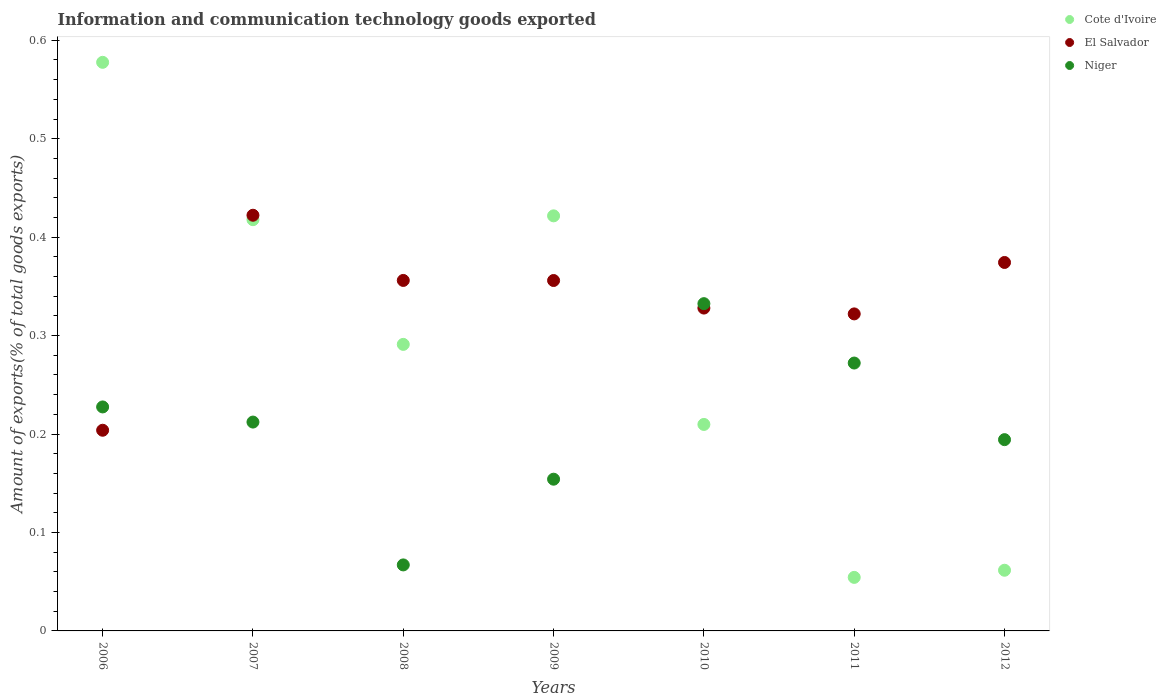Is the number of dotlines equal to the number of legend labels?
Provide a succinct answer. Yes. What is the amount of goods exported in Niger in 2007?
Provide a short and direct response. 0.21. Across all years, what is the maximum amount of goods exported in El Salvador?
Your response must be concise. 0.42. Across all years, what is the minimum amount of goods exported in Niger?
Offer a terse response. 0.07. In which year was the amount of goods exported in El Salvador minimum?
Provide a succinct answer. 2006. What is the total amount of goods exported in Cote d'Ivoire in the graph?
Keep it short and to the point. 2.03. What is the difference between the amount of goods exported in El Salvador in 2008 and that in 2011?
Provide a short and direct response. 0.03. What is the difference between the amount of goods exported in El Salvador in 2009 and the amount of goods exported in Niger in 2008?
Provide a short and direct response. 0.29. What is the average amount of goods exported in Cote d'Ivoire per year?
Your answer should be very brief. 0.29. In the year 2008, what is the difference between the amount of goods exported in Niger and amount of goods exported in Cote d'Ivoire?
Make the answer very short. -0.22. What is the ratio of the amount of goods exported in El Salvador in 2010 to that in 2011?
Your answer should be very brief. 1.02. What is the difference between the highest and the second highest amount of goods exported in Niger?
Provide a short and direct response. 0.06. What is the difference between the highest and the lowest amount of goods exported in Cote d'Ivoire?
Make the answer very short. 0.52. Is it the case that in every year, the sum of the amount of goods exported in Niger and amount of goods exported in Cote d'Ivoire  is greater than the amount of goods exported in El Salvador?
Provide a succinct answer. No. Does the amount of goods exported in Cote d'Ivoire monotonically increase over the years?
Offer a terse response. No. How many years are there in the graph?
Offer a terse response. 7. What is the difference between two consecutive major ticks on the Y-axis?
Keep it short and to the point. 0.1. Are the values on the major ticks of Y-axis written in scientific E-notation?
Offer a very short reply. No. Does the graph contain any zero values?
Provide a succinct answer. No. Where does the legend appear in the graph?
Ensure brevity in your answer.  Top right. How many legend labels are there?
Offer a terse response. 3. How are the legend labels stacked?
Your answer should be compact. Vertical. What is the title of the graph?
Your response must be concise. Information and communication technology goods exported. What is the label or title of the Y-axis?
Keep it short and to the point. Amount of exports(% of total goods exports). What is the Amount of exports(% of total goods exports) in Cote d'Ivoire in 2006?
Ensure brevity in your answer.  0.58. What is the Amount of exports(% of total goods exports) of El Salvador in 2006?
Make the answer very short. 0.2. What is the Amount of exports(% of total goods exports) of Niger in 2006?
Keep it short and to the point. 0.23. What is the Amount of exports(% of total goods exports) in Cote d'Ivoire in 2007?
Your answer should be compact. 0.42. What is the Amount of exports(% of total goods exports) in El Salvador in 2007?
Give a very brief answer. 0.42. What is the Amount of exports(% of total goods exports) in Niger in 2007?
Keep it short and to the point. 0.21. What is the Amount of exports(% of total goods exports) in Cote d'Ivoire in 2008?
Provide a short and direct response. 0.29. What is the Amount of exports(% of total goods exports) of El Salvador in 2008?
Give a very brief answer. 0.36. What is the Amount of exports(% of total goods exports) in Niger in 2008?
Your answer should be very brief. 0.07. What is the Amount of exports(% of total goods exports) of Cote d'Ivoire in 2009?
Your answer should be very brief. 0.42. What is the Amount of exports(% of total goods exports) of El Salvador in 2009?
Offer a very short reply. 0.36. What is the Amount of exports(% of total goods exports) in Niger in 2009?
Offer a terse response. 0.15. What is the Amount of exports(% of total goods exports) in Cote d'Ivoire in 2010?
Provide a short and direct response. 0.21. What is the Amount of exports(% of total goods exports) in El Salvador in 2010?
Give a very brief answer. 0.33. What is the Amount of exports(% of total goods exports) of Niger in 2010?
Offer a very short reply. 0.33. What is the Amount of exports(% of total goods exports) of Cote d'Ivoire in 2011?
Offer a very short reply. 0.05. What is the Amount of exports(% of total goods exports) in El Salvador in 2011?
Your response must be concise. 0.32. What is the Amount of exports(% of total goods exports) in Niger in 2011?
Offer a terse response. 0.27. What is the Amount of exports(% of total goods exports) in Cote d'Ivoire in 2012?
Your answer should be compact. 0.06. What is the Amount of exports(% of total goods exports) of El Salvador in 2012?
Provide a succinct answer. 0.37. What is the Amount of exports(% of total goods exports) in Niger in 2012?
Provide a succinct answer. 0.19. Across all years, what is the maximum Amount of exports(% of total goods exports) in Cote d'Ivoire?
Offer a very short reply. 0.58. Across all years, what is the maximum Amount of exports(% of total goods exports) of El Salvador?
Give a very brief answer. 0.42. Across all years, what is the maximum Amount of exports(% of total goods exports) in Niger?
Ensure brevity in your answer.  0.33. Across all years, what is the minimum Amount of exports(% of total goods exports) of Cote d'Ivoire?
Your answer should be very brief. 0.05. Across all years, what is the minimum Amount of exports(% of total goods exports) of El Salvador?
Your answer should be very brief. 0.2. Across all years, what is the minimum Amount of exports(% of total goods exports) in Niger?
Your answer should be compact. 0.07. What is the total Amount of exports(% of total goods exports) in Cote d'Ivoire in the graph?
Offer a terse response. 2.03. What is the total Amount of exports(% of total goods exports) of El Salvador in the graph?
Your answer should be very brief. 2.36. What is the total Amount of exports(% of total goods exports) in Niger in the graph?
Provide a short and direct response. 1.46. What is the difference between the Amount of exports(% of total goods exports) in Cote d'Ivoire in 2006 and that in 2007?
Keep it short and to the point. 0.16. What is the difference between the Amount of exports(% of total goods exports) in El Salvador in 2006 and that in 2007?
Provide a succinct answer. -0.22. What is the difference between the Amount of exports(% of total goods exports) of Niger in 2006 and that in 2007?
Provide a short and direct response. 0.02. What is the difference between the Amount of exports(% of total goods exports) in Cote d'Ivoire in 2006 and that in 2008?
Provide a succinct answer. 0.29. What is the difference between the Amount of exports(% of total goods exports) in El Salvador in 2006 and that in 2008?
Provide a short and direct response. -0.15. What is the difference between the Amount of exports(% of total goods exports) in Niger in 2006 and that in 2008?
Ensure brevity in your answer.  0.16. What is the difference between the Amount of exports(% of total goods exports) of Cote d'Ivoire in 2006 and that in 2009?
Provide a succinct answer. 0.16. What is the difference between the Amount of exports(% of total goods exports) of El Salvador in 2006 and that in 2009?
Your answer should be compact. -0.15. What is the difference between the Amount of exports(% of total goods exports) in Niger in 2006 and that in 2009?
Your response must be concise. 0.07. What is the difference between the Amount of exports(% of total goods exports) in Cote d'Ivoire in 2006 and that in 2010?
Make the answer very short. 0.37. What is the difference between the Amount of exports(% of total goods exports) in El Salvador in 2006 and that in 2010?
Your answer should be compact. -0.12. What is the difference between the Amount of exports(% of total goods exports) of Niger in 2006 and that in 2010?
Keep it short and to the point. -0.1. What is the difference between the Amount of exports(% of total goods exports) of Cote d'Ivoire in 2006 and that in 2011?
Provide a short and direct response. 0.52. What is the difference between the Amount of exports(% of total goods exports) in El Salvador in 2006 and that in 2011?
Your answer should be very brief. -0.12. What is the difference between the Amount of exports(% of total goods exports) in Niger in 2006 and that in 2011?
Provide a short and direct response. -0.04. What is the difference between the Amount of exports(% of total goods exports) in Cote d'Ivoire in 2006 and that in 2012?
Ensure brevity in your answer.  0.52. What is the difference between the Amount of exports(% of total goods exports) in El Salvador in 2006 and that in 2012?
Ensure brevity in your answer.  -0.17. What is the difference between the Amount of exports(% of total goods exports) in Niger in 2006 and that in 2012?
Provide a succinct answer. 0.03. What is the difference between the Amount of exports(% of total goods exports) in Cote d'Ivoire in 2007 and that in 2008?
Your response must be concise. 0.13. What is the difference between the Amount of exports(% of total goods exports) of El Salvador in 2007 and that in 2008?
Your answer should be very brief. 0.07. What is the difference between the Amount of exports(% of total goods exports) of Niger in 2007 and that in 2008?
Ensure brevity in your answer.  0.15. What is the difference between the Amount of exports(% of total goods exports) of Cote d'Ivoire in 2007 and that in 2009?
Offer a very short reply. -0. What is the difference between the Amount of exports(% of total goods exports) of El Salvador in 2007 and that in 2009?
Your answer should be very brief. 0.07. What is the difference between the Amount of exports(% of total goods exports) of Niger in 2007 and that in 2009?
Provide a succinct answer. 0.06. What is the difference between the Amount of exports(% of total goods exports) in Cote d'Ivoire in 2007 and that in 2010?
Provide a short and direct response. 0.21. What is the difference between the Amount of exports(% of total goods exports) of El Salvador in 2007 and that in 2010?
Your response must be concise. 0.09. What is the difference between the Amount of exports(% of total goods exports) in Niger in 2007 and that in 2010?
Make the answer very short. -0.12. What is the difference between the Amount of exports(% of total goods exports) of Cote d'Ivoire in 2007 and that in 2011?
Your answer should be compact. 0.36. What is the difference between the Amount of exports(% of total goods exports) in El Salvador in 2007 and that in 2011?
Give a very brief answer. 0.1. What is the difference between the Amount of exports(% of total goods exports) in Niger in 2007 and that in 2011?
Your answer should be compact. -0.06. What is the difference between the Amount of exports(% of total goods exports) in Cote d'Ivoire in 2007 and that in 2012?
Provide a succinct answer. 0.36. What is the difference between the Amount of exports(% of total goods exports) in El Salvador in 2007 and that in 2012?
Ensure brevity in your answer.  0.05. What is the difference between the Amount of exports(% of total goods exports) of Niger in 2007 and that in 2012?
Ensure brevity in your answer.  0.02. What is the difference between the Amount of exports(% of total goods exports) of Cote d'Ivoire in 2008 and that in 2009?
Keep it short and to the point. -0.13. What is the difference between the Amount of exports(% of total goods exports) of El Salvador in 2008 and that in 2009?
Your response must be concise. 0. What is the difference between the Amount of exports(% of total goods exports) of Niger in 2008 and that in 2009?
Offer a terse response. -0.09. What is the difference between the Amount of exports(% of total goods exports) in Cote d'Ivoire in 2008 and that in 2010?
Give a very brief answer. 0.08. What is the difference between the Amount of exports(% of total goods exports) in El Salvador in 2008 and that in 2010?
Ensure brevity in your answer.  0.03. What is the difference between the Amount of exports(% of total goods exports) in Niger in 2008 and that in 2010?
Your response must be concise. -0.27. What is the difference between the Amount of exports(% of total goods exports) of Cote d'Ivoire in 2008 and that in 2011?
Offer a terse response. 0.24. What is the difference between the Amount of exports(% of total goods exports) in El Salvador in 2008 and that in 2011?
Your response must be concise. 0.03. What is the difference between the Amount of exports(% of total goods exports) in Niger in 2008 and that in 2011?
Provide a succinct answer. -0.21. What is the difference between the Amount of exports(% of total goods exports) in Cote d'Ivoire in 2008 and that in 2012?
Your answer should be compact. 0.23. What is the difference between the Amount of exports(% of total goods exports) in El Salvador in 2008 and that in 2012?
Offer a very short reply. -0.02. What is the difference between the Amount of exports(% of total goods exports) in Niger in 2008 and that in 2012?
Your answer should be very brief. -0.13. What is the difference between the Amount of exports(% of total goods exports) in Cote d'Ivoire in 2009 and that in 2010?
Provide a short and direct response. 0.21. What is the difference between the Amount of exports(% of total goods exports) of El Salvador in 2009 and that in 2010?
Offer a terse response. 0.03. What is the difference between the Amount of exports(% of total goods exports) in Niger in 2009 and that in 2010?
Provide a succinct answer. -0.18. What is the difference between the Amount of exports(% of total goods exports) of Cote d'Ivoire in 2009 and that in 2011?
Offer a terse response. 0.37. What is the difference between the Amount of exports(% of total goods exports) in El Salvador in 2009 and that in 2011?
Provide a succinct answer. 0.03. What is the difference between the Amount of exports(% of total goods exports) of Niger in 2009 and that in 2011?
Give a very brief answer. -0.12. What is the difference between the Amount of exports(% of total goods exports) of Cote d'Ivoire in 2009 and that in 2012?
Keep it short and to the point. 0.36. What is the difference between the Amount of exports(% of total goods exports) in El Salvador in 2009 and that in 2012?
Offer a terse response. -0.02. What is the difference between the Amount of exports(% of total goods exports) in Niger in 2009 and that in 2012?
Provide a short and direct response. -0.04. What is the difference between the Amount of exports(% of total goods exports) of Cote d'Ivoire in 2010 and that in 2011?
Give a very brief answer. 0.16. What is the difference between the Amount of exports(% of total goods exports) of El Salvador in 2010 and that in 2011?
Your answer should be very brief. 0.01. What is the difference between the Amount of exports(% of total goods exports) in Niger in 2010 and that in 2011?
Provide a short and direct response. 0.06. What is the difference between the Amount of exports(% of total goods exports) of Cote d'Ivoire in 2010 and that in 2012?
Provide a succinct answer. 0.15. What is the difference between the Amount of exports(% of total goods exports) of El Salvador in 2010 and that in 2012?
Give a very brief answer. -0.05. What is the difference between the Amount of exports(% of total goods exports) of Niger in 2010 and that in 2012?
Your response must be concise. 0.14. What is the difference between the Amount of exports(% of total goods exports) in Cote d'Ivoire in 2011 and that in 2012?
Make the answer very short. -0.01. What is the difference between the Amount of exports(% of total goods exports) in El Salvador in 2011 and that in 2012?
Provide a short and direct response. -0.05. What is the difference between the Amount of exports(% of total goods exports) in Niger in 2011 and that in 2012?
Offer a terse response. 0.08. What is the difference between the Amount of exports(% of total goods exports) of Cote d'Ivoire in 2006 and the Amount of exports(% of total goods exports) of El Salvador in 2007?
Your answer should be compact. 0.16. What is the difference between the Amount of exports(% of total goods exports) in Cote d'Ivoire in 2006 and the Amount of exports(% of total goods exports) in Niger in 2007?
Ensure brevity in your answer.  0.37. What is the difference between the Amount of exports(% of total goods exports) in El Salvador in 2006 and the Amount of exports(% of total goods exports) in Niger in 2007?
Make the answer very short. -0.01. What is the difference between the Amount of exports(% of total goods exports) in Cote d'Ivoire in 2006 and the Amount of exports(% of total goods exports) in El Salvador in 2008?
Your answer should be compact. 0.22. What is the difference between the Amount of exports(% of total goods exports) in Cote d'Ivoire in 2006 and the Amount of exports(% of total goods exports) in Niger in 2008?
Offer a terse response. 0.51. What is the difference between the Amount of exports(% of total goods exports) of El Salvador in 2006 and the Amount of exports(% of total goods exports) of Niger in 2008?
Offer a very short reply. 0.14. What is the difference between the Amount of exports(% of total goods exports) of Cote d'Ivoire in 2006 and the Amount of exports(% of total goods exports) of El Salvador in 2009?
Your answer should be very brief. 0.22. What is the difference between the Amount of exports(% of total goods exports) of Cote d'Ivoire in 2006 and the Amount of exports(% of total goods exports) of Niger in 2009?
Your answer should be very brief. 0.42. What is the difference between the Amount of exports(% of total goods exports) in El Salvador in 2006 and the Amount of exports(% of total goods exports) in Niger in 2009?
Offer a very short reply. 0.05. What is the difference between the Amount of exports(% of total goods exports) of Cote d'Ivoire in 2006 and the Amount of exports(% of total goods exports) of El Salvador in 2010?
Ensure brevity in your answer.  0.25. What is the difference between the Amount of exports(% of total goods exports) in Cote d'Ivoire in 2006 and the Amount of exports(% of total goods exports) in Niger in 2010?
Offer a terse response. 0.25. What is the difference between the Amount of exports(% of total goods exports) in El Salvador in 2006 and the Amount of exports(% of total goods exports) in Niger in 2010?
Your response must be concise. -0.13. What is the difference between the Amount of exports(% of total goods exports) in Cote d'Ivoire in 2006 and the Amount of exports(% of total goods exports) in El Salvador in 2011?
Ensure brevity in your answer.  0.26. What is the difference between the Amount of exports(% of total goods exports) in Cote d'Ivoire in 2006 and the Amount of exports(% of total goods exports) in Niger in 2011?
Provide a succinct answer. 0.31. What is the difference between the Amount of exports(% of total goods exports) in El Salvador in 2006 and the Amount of exports(% of total goods exports) in Niger in 2011?
Offer a very short reply. -0.07. What is the difference between the Amount of exports(% of total goods exports) of Cote d'Ivoire in 2006 and the Amount of exports(% of total goods exports) of El Salvador in 2012?
Your answer should be very brief. 0.2. What is the difference between the Amount of exports(% of total goods exports) in Cote d'Ivoire in 2006 and the Amount of exports(% of total goods exports) in Niger in 2012?
Provide a succinct answer. 0.38. What is the difference between the Amount of exports(% of total goods exports) of El Salvador in 2006 and the Amount of exports(% of total goods exports) of Niger in 2012?
Your response must be concise. 0.01. What is the difference between the Amount of exports(% of total goods exports) in Cote d'Ivoire in 2007 and the Amount of exports(% of total goods exports) in El Salvador in 2008?
Keep it short and to the point. 0.06. What is the difference between the Amount of exports(% of total goods exports) of Cote d'Ivoire in 2007 and the Amount of exports(% of total goods exports) of Niger in 2008?
Your answer should be compact. 0.35. What is the difference between the Amount of exports(% of total goods exports) of El Salvador in 2007 and the Amount of exports(% of total goods exports) of Niger in 2008?
Ensure brevity in your answer.  0.36. What is the difference between the Amount of exports(% of total goods exports) of Cote d'Ivoire in 2007 and the Amount of exports(% of total goods exports) of El Salvador in 2009?
Offer a very short reply. 0.06. What is the difference between the Amount of exports(% of total goods exports) in Cote d'Ivoire in 2007 and the Amount of exports(% of total goods exports) in Niger in 2009?
Your response must be concise. 0.26. What is the difference between the Amount of exports(% of total goods exports) in El Salvador in 2007 and the Amount of exports(% of total goods exports) in Niger in 2009?
Make the answer very short. 0.27. What is the difference between the Amount of exports(% of total goods exports) of Cote d'Ivoire in 2007 and the Amount of exports(% of total goods exports) of El Salvador in 2010?
Offer a terse response. 0.09. What is the difference between the Amount of exports(% of total goods exports) of Cote d'Ivoire in 2007 and the Amount of exports(% of total goods exports) of Niger in 2010?
Give a very brief answer. 0.09. What is the difference between the Amount of exports(% of total goods exports) in El Salvador in 2007 and the Amount of exports(% of total goods exports) in Niger in 2010?
Give a very brief answer. 0.09. What is the difference between the Amount of exports(% of total goods exports) in Cote d'Ivoire in 2007 and the Amount of exports(% of total goods exports) in El Salvador in 2011?
Provide a short and direct response. 0.1. What is the difference between the Amount of exports(% of total goods exports) of Cote d'Ivoire in 2007 and the Amount of exports(% of total goods exports) of Niger in 2011?
Provide a succinct answer. 0.15. What is the difference between the Amount of exports(% of total goods exports) of El Salvador in 2007 and the Amount of exports(% of total goods exports) of Niger in 2011?
Your answer should be very brief. 0.15. What is the difference between the Amount of exports(% of total goods exports) in Cote d'Ivoire in 2007 and the Amount of exports(% of total goods exports) in El Salvador in 2012?
Your answer should be compact. 0.04. What is the difference between the Amount of exports(% of total goods exports) of Cote d'Ivoire in 2007 and the Amount of exports(% of total goods exports) of Niger in 2012?
Provide a succinct answer. 0.22. What is the difference between the Amount of exports(% of total goods exports) in El Salvador in 2007 and the Amount of exports(% of total goods exports) in Niger in 2012?
Provide a succinct answer. 0.23. What is the difference between the Amount of exports(% of total goods exports) of Cote d'Ivoire in 2008 and the Amount of exports(% of total goods exports) of El Salvador in 2009?
Your answer should be very brief. -0.06. What is the difference between the Amount of exports(% of total goods exports) of Cote d'Ivoire in 2008 and the Amount of exports(% of total goods exports) of Niger in 2009?
Ensure brevity in your answer.  0.14. What is the difference between the Amount of exports(% of total goods exports) of El Salvador in 2008 and the Amount of exports(% of total goods exports) of Niger in 2009?
Give a very brief answer. 0.2. What is the difference between the Amount of exports(% of total goods exports) in Cote d'Ivoire in 2008 and the Amount of exports(% of total goods exports) in El Salvador in 2010?
Offer a very short reply. -0.04. What is the difference between the Amount of exports(% of total goods exports) of Cote d'Ivoire in 2008 and the Amount of exports(% of total goods exports) of Niger in 2010?
Offer a terse response. -0.04. What is the difference between the Amount of exports(% of total goods exports) in El Salvador in 2008 and the Amount of exports(% of total goods exports) in Niger in 2010?
Offer a very short reply. 0.02. What is the difference between the Amount of exports(% of total goods exports) in Cote d'Ivoire in 2008 and the Amount of exports(% of total goods exports) in El Salvador in 2011?
Your answer should be compact. -0.03. What is the difference between the Amount of exports(% of total goods exports) of Cote d'Ivoire in 2008 and the Amount of exports(% of total goods exports) of Niger in 2011?
Your answer should be very brief. 0.02. What is the difference between the Amount of exports(% of total goods exports) in El Salvador in 2008 and the Amount of exports(% of total goods exports) in Niger in 2011?
Provide a succinct answer. 0.08. What is the difference between the Amount of exports(% of total goods exports) in Cote d'Ivoire in 2008 and the Amount of exports(% of total goods exports) in El Salvador in 2012?
Provide a succinct answer. -0.08. What is the difference between the Amount of exports(% of total goods exports) in Cote d'Ivoire in 2008 and the Amount of exports(% of total goods exports) in Niger in 2012?
Keep it short and to the point. 0.1. What is the difference between the Amount of exports(% of total goods exports) of El Salvador in 2008 and the Amount of exports(% of total goods exports) of Niger in 2012?
Keep it short and to the point. 0.16. What is the difference between the Amount of exports(% of total goods exports) in Cote d'Ivoire in 2009 and the Amount of exports(% of total goods exports) in El Salvador in 2010?
Give a very brief answer. 0.09. What is the difference between the Amount of exports(% of total goods exports) in Cote d'Ivoire in 2009 and the Amount of exports(% of total goods exports) in Niger in 2010?
Provide a short and direct response. 0.09. What is the difference between the Amount of exports(% of total goods exports) of El Salvador in 2009 and the Amount of exports(% of total goods exports) of Niger in 2010?
Offer a terse response. 0.02. What is the difference between the Amount of exports(% of total goods exports) of Cote d'Ivoire in 2009 and the Amount of exports(% of total goods exports) of El Salvador in 2011?
Ensure brevity in your answer.  0.1. What is the difference between the Amount of exports(% of total goods exports) in Cote d'Ivoire in 2009 and the Amount of exports(% of total goods exports) in Niger in 2011?
Give a very brief answer. 0.15. What is the difference between the Amount of exports(% of total goods exports) of El Salvador in 2009 and the Amount of exports(% of total goods exports) of Niger in 2011?
Offer a very short reply. 0.08. What is the difference between the Amount of exports(% of total goods exports) in Cote d'Ivoire in 2009 and the Amount of exports(% of total goods exports) in El Salvador in 2012?
Keep it short and to the point. 0.05. What is the difference between the Amount of exports(% of total goods exports) of Cote d'Ivoire in 2009 and the Amount of exports(% of total goods exports) of Niger in 2012?
Make the answer very short. 0.23. What is the difference between the Amount of exports(% of total goods exports) of El Salvador in 2009 and the Amount of exports(% of total goods exports) of Niger in 2012?
Provide a short and direct response. 0.16. What is the difference between the Amount of exports(% of total goods exports) of Cote d'Ivoire in 2010 and the Amount of exports(% of total goods exports) of El Salvador in 2011?
Offer a very short reply. -0.11. What is the difference between the Amount of exports(% of total goods exports) in Cote d'Ivoire in 2010 and the Amount of exports(% of total goods exports) in Niger in 2011?
Offer a very short reply. -0.06. What is the difference between the Amount of exports(% of total goods exports) of El Salvador in 2010 and the Amount of exports(% of total goods exports) of Niger in 2011?
Give a very brief answer. 0.06. What is the difference between the Amount of exports(% of total goods exports) in Cote d'Ivoire in 2010 and the Amount of exports(% of total goods exports) in El Salvador in 2012?
Make the answer very short. -0.16. What is the difference between the Amount of exports(% of total goods exports) of Cote d'Ivoire in 2010 and the Amount of exports(% of total goods exports) of Niger in 2012?
Provide a short and direct response. 0.02. What is the difference between the Amount of exports(% of total goods exports) in El Salvador in 2010 and the Amount of exports(% of total goods exports) in Niger in 2012?
Keep it short and to the point. 0.13. What is the difference between the Amount of exports(% of total goods exports) of Cote d'Ivoire in 2011 and the Amount of exports(% of total goods exports) of El Salvador in 2012?
Provide a succinct answer. -0.32. What is the difference between the Amount of exports(% of total goods exports) in Cote d'Ivoire in 2011 and the Amount of exports(% of total goods exports) in Niger in 2012?
Make the answer very short. -0.14. What is the difference between the Amount of exports(% of total goods exports) of El Salvador in 2011 and the Amount of exports(% of total goods exports) of Niger in 2012?
Offer a very short reply. 0.13. What is the average Amount of exports(% of total goods exports) in Cote d'Ivoire per year?
Your answer should be very brief. 0.29. What is the average Amount of exports(% of total goods exports) of El Salvador per year?
Provide a short and direct response. 0.34. What is the average Amount of exports(% of total goods exports) of Niger per year?
Keep it short and to the point. 0.21. In the year 2006, what is the difference between the Amount of exports(% of total goods exports) in Cote d'Ivoire and Amount of exports(% of total goods exports) in El Salvador?
Your answer should be very brief. 0.37. In the year 2006, what is the difference between the Amount of exports(% of total goods exports) of Cote d'Ivoire and Amount of exports(% of total goods exports) of Niger?
Keep it short and to the point. 0.35. In the year 2006, what is the difference between the Amount of exports(% of total goods exports) of El Salvador and Amount of exports(% of total goods exports) of Niger?
Provide a short and direct response. -0.02. In the year 2007, what is the difference between the Amount of exports(% of total goods exports) in Cote d'Ivoire and Amount of exports(% of total goods exports) in El Salvador?
Make the answer very short. -0. In the year 2007, what is the difference between the Amount of exports(% of total goods exports) of Cote d'Ivoire and Amount of exports(% of total goods exports) of Niger?
Your response must be concise. 0.21. In the year 2007, what is the difference between the Amount of exports(% of total goods exports) in El Salvador and Amount of exports(% of total goods exports) in Niger?
Keep it short and to the point. 0.21. In the year 2008, what is the difference between the Amount of exports(% of total goods exports) of Cote d'Ivoire and Amount of exports(% of total goods exports) of El Salvador?
Offer a very short reply. -0.07. In the year 2008, what is the difference between the Amount of exports(% of total goods exports) in Cote d'Ivoire and Amount of exports(% of total goods exports) in Niger?
Ensure brevity in your answer.  0.22. In the year 2008, what is the difference between the Amount of exports(% of total goods exports) of El Salvador and Amount of exports(% of total goods exports) of Niger?
Provide a short and direct response. 0.29. In the year 2009, what is the difference between the Amount of exports(% of total goods exports) in Cote d'Ivoire and Amount of exports(% of total goods exports) in El Salvador?
Provide a succinct answer. 0.07. In the year 2009, what is the difference between the Amount of exports(% of total goods exports) of Cote d'Ivoire and Amount of exports(% of total goods exports) of Niger?
Ensure brevity in your answer.  0.27. In the year 2009, what is the difference between the Amount of exports(% of total goods exports) in El Salvador and Amount of exports(% of total goods exports) in Niger?
Provide a succinct answer. 0.2. In the year 2010, what is the difference between the Amount of exports(% of total goods exports) in Cote d'Ivoire and Amount of exports(% of total goods exports) in El Salvador?
Your answer should be very brief. -0.12. In the year 2010, what is the difference between the Amount of exports(% of total goods exports) in Cote d'Ivoire and Amount of exports(% of total goods exports) in Niger?
Offer a terse response. -0.12. In the year 2010, what is the difference between the Amount of exports(% of total goods exports) in El Salvador and Amount of exports(% of total goods exports) in Niger?
Your answer should be very brief. -0. In the year 2011, what is the difference between the Amount of exports(% of total goods exports) in Cote d'Ivoire and Amount of exports(% of total goods exports) in El Salvador?
Your answer should be very brief. -0.27. In the year 2011, what is the difference between the Amount of exports(% of total goods exports) in Cote d'Ivoire and Amount of exports(% of total goods exports) in Niger?
Give a very brief answer. -0.22. In the year 2011, what is the difference between the Amount of exports(% of total goods exports) of El Salvador and Amount of exports(% of total goods exports) of Niger?
Keep it short and to the point. 0.05. In the year 2012, what is the difference between the Amount of exports(% of total goods exports) of Cote d'Ivoire and Amount of exports(% of total goods exports) of El Salvador?
Provide a short and direct response. -0.31. In the year 2012, what is the difference between the Amount of exports(% of total goods exports) of Cote d'Ivoire and Amount of exports(% of total goods exports) of Niger?
Make the answer very short. -0.13. In the year 2012, what is the difference between the Amount of exports(% of total goods exports) in El Salvador and Amount of exports(% of total goods exports) in Niger?
Keep it short and to the point. 0.18. What is the ratio of the Amount of exports(% of total goods exports) of Cote d'Ivoire in 2006 to that in 2007?
Give a very brief answer. 1.38. What is the ratio of the Amount of exports(% of total goods exports) in El Salvador in 2006 to that in 2007?
Ensure brevity in your answer.  0.48. What is the ratio of the Amount of exports(% of total goods exports) in Niger in 2006 to that in 2007?
Give a very brief answer. 1.07. What is the ratio of the Amount of exports(% of total goods exports) in Cote d'Ivoire in 2006 to that in 2008?
Provide a succinct answer. 1.98. What is the ratio of the Amount of exports(% of total goods exports) of El Salvador in 2006 to that in 2008?
Provide a short and direct response. 0.57. What is the ratio of the Amount of exports(% of total goods exports) of Niger in 2006 to that in 2008?
Give a very brief answer. 3.39. What is the ratio of the Amount of exports(% of total goods exports) in Cote d'Ivoire in 2006 to that in 2009?
Offer a very short reply. 1.37. What is the ratio of the Amount of exports(% of total goods exports) of El Salvador in 2006 to that in 2009?
Offer a terse response. 0.57. What is the ratio of the Amount of exports(% of total goods exports) in Niger in 2006 to that in 2009?
Keep it short and to the point. 1.48. What is the ratio of the Amount of exports(% of total goods exports) in Cote d'Ivoire in 2006 to that in 2010?
Your answer should be compact. 2.75. What is the ratio of the Amount of exports(% of total goods exports) in El Salvador in 2006 to that in 2010?
Your answer should be compact. 0.62. What is the ratio of the Amount of exports(% of total goods exports) in Niger in 2006 to that in 2010?
Provide a succinct answer. 0.68. What is the ratio of the Amount of exports(% of total goods exports) in Cote d'Ivoire in 2006 to that in 2011?
Offer a terse response. 10.62. What is the ratio of the Amount of exports(% of total goods exports) of El Salvador in 2006 to that in 2011?
Your answer should be very brief. 0.63. What is the ratio of the Amount of exports(% of total goods exports) in Niger in 2006 to that in 2011?
Your answer should be compact. 0.84. What is the ratio of the Amount of exports(% of total goods exports) in Cote d'Ivoire in 2006 to that in 2012?
Your answer should be very brief. 9.37. What is the ratio of the Amount of exports(% of total goods exports) in El Salvador in 2006 to that in 2012?
Provide a succinct answer. 0.54. What is the ratio of the Amount of exports(% of total goods exports) in Niger in 2006 to that in 2012?
Your answer should be compact. 1.17. What is the ratio of the Amount of exports(% of total goods exports) of Cote d'Ivoire in 2007 to that in 2008?
Provide a short and direct response. 1.44. What is the ratio of the Amount of exports(% of total goods exports) in El Salvador in 2007 to that in 2008?
Your answer should be very brief. 1.19. What is the ratio of the Amount of exports(% of total goods exports) in Niger in 2007 to that in 2008?
Your answer should be compact. 3.16. What is the ratio of the Amount of exports(% of total goods exports) in El Salvador in 2007 to that in 2009?
Your answer should be compact. 1.19. What is the ratio of the Amount of exports(% of total goods exports) of Niger in 2007 to that in 2009?
Make the answer very short. 1.38. What is the ratio of the Amount of exports(% of total goods exports) of Cote d'Ivoire in 2007 to that in 2010?
Keep it short and to the point. 1.99. What is the ratio of the Amount of exports(% of total goods exports) of El Salvador in 2007 to that in 2010?
Provide a succinct answer. 1.29. What is the ratio of the Amount of exports(% of total goods exports) in Niger in 2007 to that in 2010?
Make the answer very short. 0.64. What is the ratio of the Amount of exports(% of total goods exports) in Cote d'Ivoire in 2007 to that in 2011?
Make the answer very short. 7.68. What is the ratio of the Amount of exports(% of total goods exports) of El Salvador in 2007 to that in 2011?
Offer a very short reply. 1.31. What is the ratio of the Amount of exports(% of total goods exports) in Niger in 2007 to that in 2011?
Give a very brief answer. 0.78. What is the ratio of the Amount of exports(% of total goods exports) in Cote d'Ivoire in 2007 to that in 2012?
Your answer should be compact. 6.78. What is the ratio of the Amount of exports(% of total goods exports) in El Salvador in 2007 to that in 2012?
Your answer should be compact. 1.13. What is the ratio of the Amount of exports(% of total goods exports) in Niger in 2007 to that in 2012?
Offer a terse response. 1.09. What is the ratio of the Amount of exports(% of total goods exports) of Cote d'Ivoire in 2008 to that in 2009?
Your answer should be compact. 0.69. What is the ratio of the Amount of exports(% of total goods exports) of Niger in 2008 to that in 2009?
Provide a succinct answer. 0.44. What is the ratio of the Amount of exports(% of total goods exports) of Cote d'Ivoire in 2008 to that in 2010?
Keep it short and to the point. 1.39. What is the ratio of the Amount of exports(% of total goods exports) in El Salvador in 2008 to that in 2010?
Ensure brevity in your answer.  1.09. What is the ratio of the Amount of exports(% of total goods exports) in Niger in 2008 to that in 2010?
Offer a terse response. 0.2. What is the ratio of the Amount of exports(% of total goods exports) in Cote d'Ivoire in 2008 to that in 2011?
Make the answer very short. 5.35. What is the ratio of the Amount of exports(% of total goods exports) of El Salvador in 2008 to that in 2011?
Make the answer very short. 1.11. What is the ratio of the Amount of exports(% of total goods exports) of Niger in 2008 to that in 2011?
Provide a short and direct response. 0.25. What is the ratio of the Amount of exports(% of total goods exports) of Cote d'Ivoire in 2008 to that in 2012?
Your answer should be compact. 4.72. What is the ratio of the Amount of exports(% of total goods exports) of El Salvador in 2008 to that in 2012?
Give a very brief answer. 0.95. What is the ratio of the Amount of exports(% of total goods exports) of Niger in 2008 to that in 2012?
Give a very brief answer. 0.35. What is the ratio of the Amount of exports(% of total goods exports) of Cote d'Ivoire in 2009 to that in 2010?
Give a very brief answer. 2.01. What is the ratio of the Amount of exports(% of total goods exports) in El Salvador in 2009 to that in 2010?
Provide a short and direct response. 1.09. What is the ratio of the Amount of exports(% of total goods exports) of Niger in 2009 to that in 2010?
Provide a short and direct response. 0.46. What is the ratio of the Amount of exports(% of total goods exports) in Cote d'Ivoire in 2009 to that in 2011?
Give a very brief answer. 7.75. What is the ratio of the Amount of exports(% of total goods exports) in El Salvador in 2009 to that in 2011?
Offer a terse response. 1.11. What is the ratio of the Amount of exports(% of total goods exports) of Niger in 2009 to that in 2011?
Provide a succinct answer. 0.57. What is the ratio of the Amount of exports(% of total goods exports) of Cote d'Ivoire in 2009 to that in 2012?
Make the answer very short. 6.84. What is the ratio of the Amount of exports(% of total goods exports) in El Salvador in 2009 to that in 2012?
Provide a succinct answer. 0.95. What is the ratio of the Amount of exports(% of total goods exports) of Niger in 2009 to that in 2012?
Your answer should be compact. 0.79. What is the ratio of the Amount of exports(% of total goods exports) of Cote d'Ivoire in 2010 to that in 2011?
Keep it short and to the point. 3.86. What is the ratio of the Amount of exports(% of total goods exports) in El Salvador in 2010 to that in 2011?
Your response must be concise. 1.02. What is the ratio of the Amount of exports(% of total goods exports) of Niger in 2010 to that in 2011?
Offer a terse response. 1.22. What is the ratio of the Amount of exports(% of total goods exports) in Cote d'Ivoire in 2010 to that in 2012?
Your answer should be very brief. 3.4. What is the ratio of the Amount of exports(% of total goods exports) in El Salvador in 2010 to that in 2012?
Ensure brevity in your answer.  0.88. What is the ratio of the Amount of exports(% of total goods exports) in Niger in 2010 to that in 2012?
Provide a short and direct response. 1.71. What is the ratio of the Amount of exports(% of total goods exports) in Cote d'Ivoire in 2011 to that in 2012?
Provide a short and direct response. 0.88. What is the ratio of the Amount of exports(% of total goods exports) of El Salvador in 2011 to that in 2012?
Make the answer very short. 0.86. What is the ratio of the Amount of exports(% of total goods exports) in Niger in 2011 to that in 2012?
Offer a terse response. 1.4. What is the difference between the highest and the second highest Amount of exports(% of total goods exports) of Cote d'Ivoire?
Make the answer very short. 0.16. What is the difference between the highest and the second highest Amount of exports(% of total goods exports) in El Salvador?
Your response must be concise. 0.05. What is the difference between the highest and the second highest Amount of exports(% of total goods exports) of Niger?
Keep it short and to the point. 0.06. What is the difference between the highest and the lowest Amount of exports(% of total goods exports) of Cote d'Ivoire?
Give a very brief answer. 0.52. What is the difference between the highest and the lowest Amount of exports(% of total goods exports) in El Salvador?
Offer a terse response. 0.22. What is the difference between the highest and the lowest Amount of exports(% of total goods exports) in Niger?
Your answer should be compact. 0.27. 